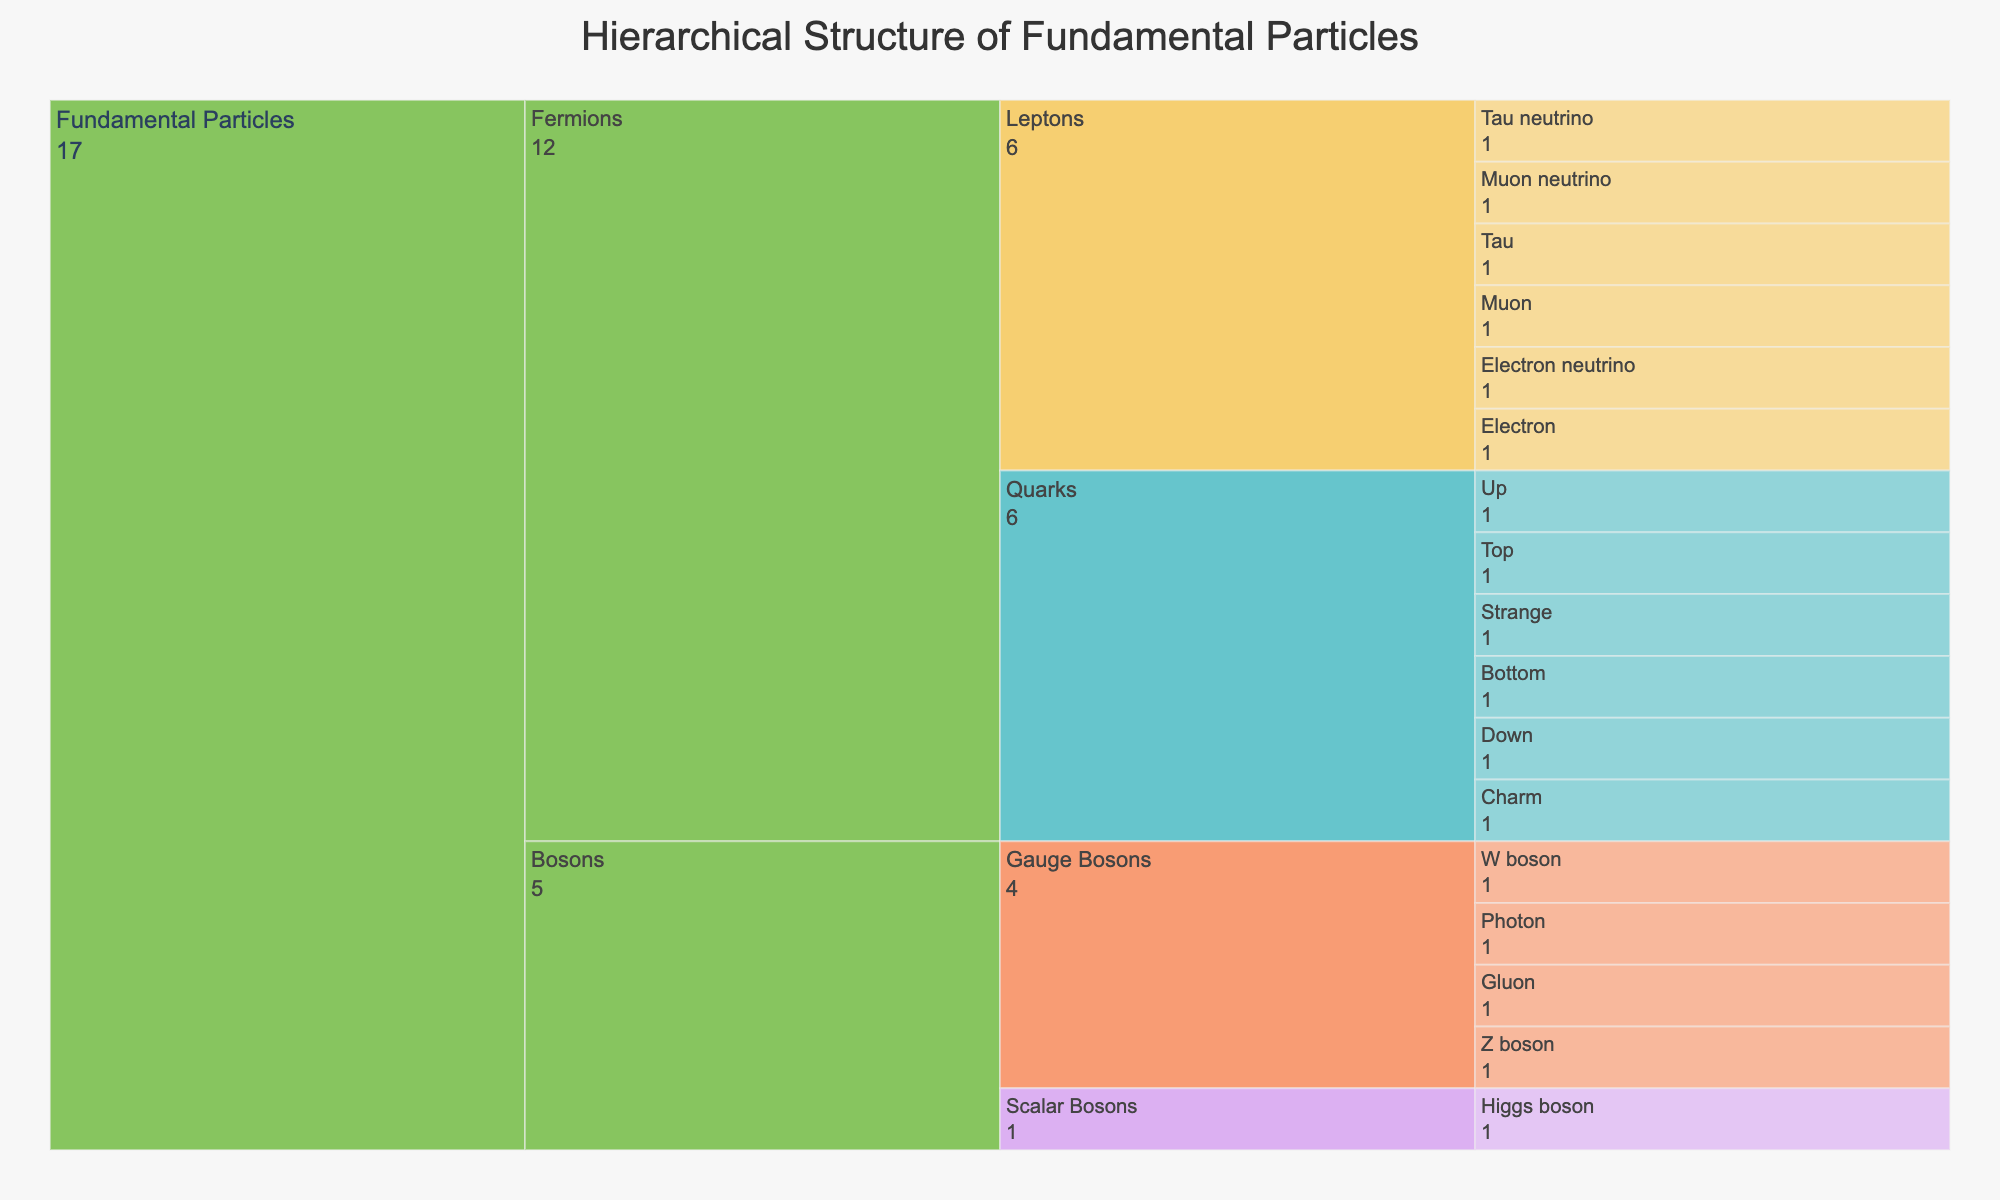What is the title of the Icicle chart? The title is located at the top of the chart, often in a larger and bold font compared to other text elements.
Answer: Hierarchical Structure of Fundamental Particles How many main categories are under the 'Fundamental Particles' root? The root node 'Fundamental Particles' directly branches into its main categories, which can be counted by looking at the first level.
Answer: 2 How many types of quarks are presented in the chart? Quarks are a subcategory under 'Fermions', which branches into 'Quarks'. By counting the terminal nodes under 'Quarks', we can determine the number of quark types.
Answer: 6 Which category contains the 'Photon'? The 'Photon' is under 'Gauge Bosons', which is a subcategory of 'Bosons'. We trace 'Bosons' back to the 'Fundamental Particles' root.
Answer: Bosons How many leptons are there in total? Leptons are found under 'Fermions'. By counting the individual terminal nodes under 'Leptons', we sum up the total number of leptons.
Answer: 6 Which has more particle types: Quarks or Leptons? Comparing the number of terminal nodes under 'Quarks' and 'Leptons', we can see which category has more particle types.
Answer: Quarks What is the color scheme used in this Icicle chart? The color scheme is described as 'Pastel'. Colors are assigned to 'Level2' categories such as Quarks, Leptons, Gauge Bosons, and Scalar Bosons, usually using lighter, softer colors indicative of a pastel palette.
Answer: Pastel Name all the particle categories that fall under 'Bosons'. By looking at the terminal nodes under 'Bosons', we can list out all the particle categories.
Answer: Gauge Bosons, Scalar Bosons Count the total number of individual particles represented in the chart. Summing up the terminal nodes from all branches (Quarks, Leptons, Gauge Bosons, and Scalar Bosons) gives the total number.
Answer: 17 